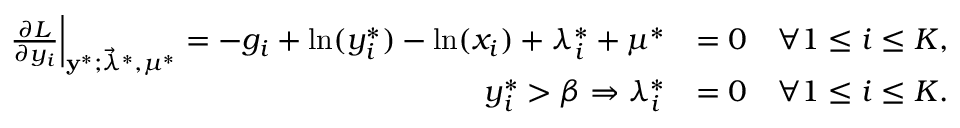<formula> <loc_0><loc_0><loc_500><loc_500>\begin{array} { r l } { \frac { \partial L } { \partial y _ { i } } \right | _ { \mathbf y ^ { * } ; \vec { \lambda } ^ { * } , \mu ^ { * } } = - g _ { i } + \ln ( y _ { i } ^ { * } ) - \ln ( x _ { i } ) + \lambda _ { i } ^ { * } + \mu ^ { * } } & { = 0 \quad \forall 1 \leq i \leq K , } \\ { y _ { i } ^ { * } > \beta \Rightarrow \lambda _ { i } ^ { * } } & { = 0 \quad \forall 1 \leq i \leq K . } \end{array}</formula> 